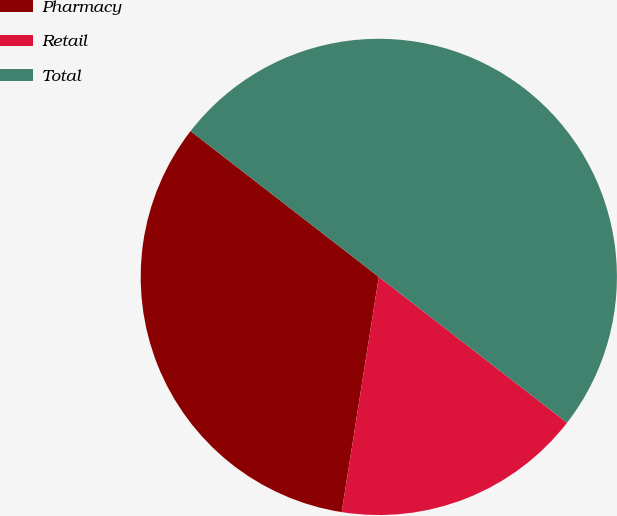Convert chart to OTSL. <chart><loc_0><loc_0><loc_500><loc_500><pie_chart><fcel>Pharmacy<fcel>Retail<fcel>Total<nl><fcel>33.0%<fcel>17.0%<fcel>50.0%<nl></chart> 